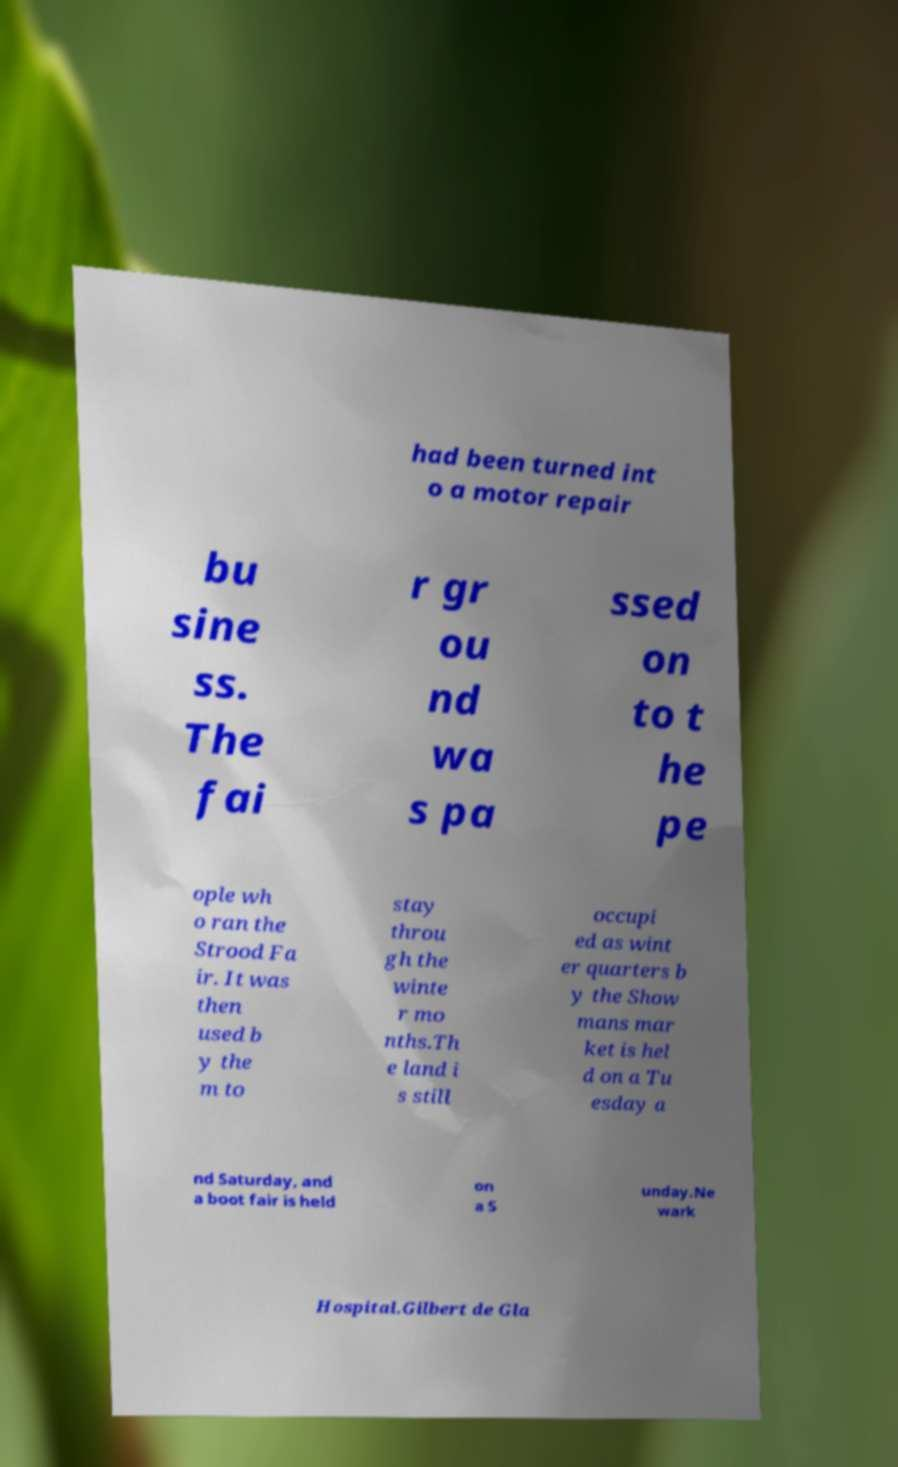Can you accurately transcribe the text from the provided image for me? had been turned int o a motor repair bu sine ss. The fai r gr ou nd wa s pa ssed on to t he pe ople wh o ran the Strood Fa ir. It was then used b y the m to stay throu gh the winte r mo nths.Th e land i s still occupi ed as wint er quarters b y the Show mans mar ket is hel d on a Tu esday a nd Saturday, and a boot fair is held on a S unday.Ne wark Hospital.Gilbert de Gla 